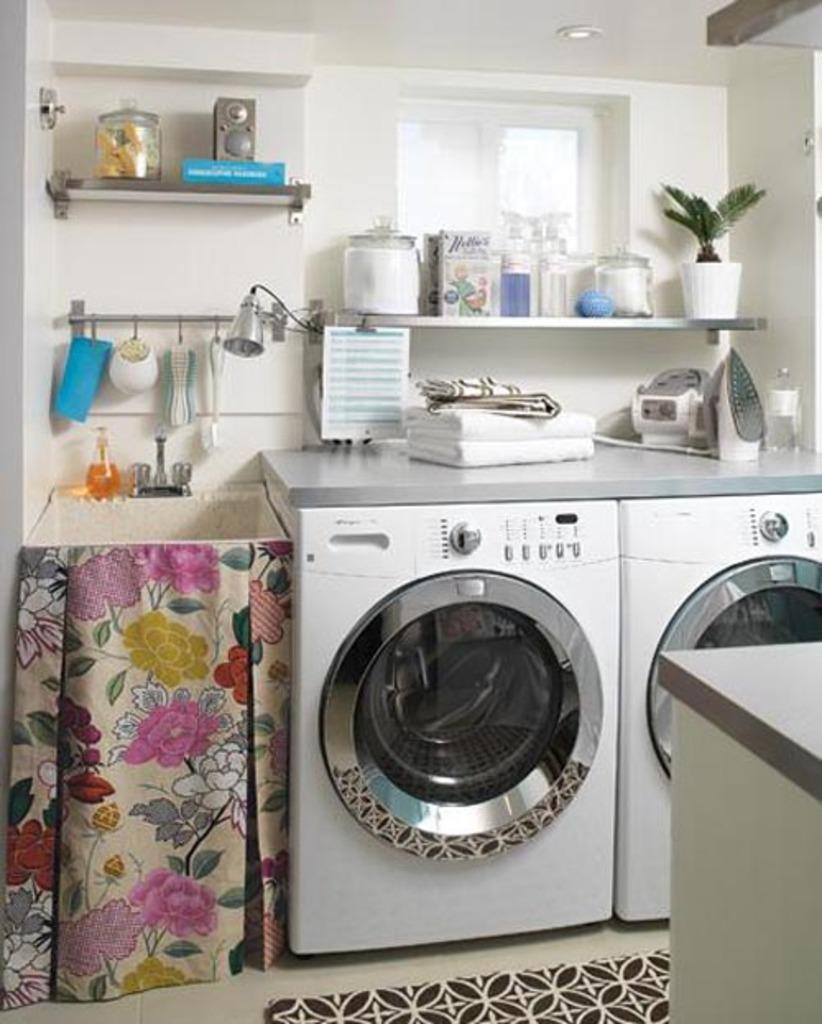How many washing machines can be seen in the image? There are two washing machines in the image. What is another appliance visible in the image? There is an iron box in the image. What items are related to laundry in the image? There are clothes and vessels in the image. What type of storage can be seen in the image? There are shelves in the image. Is there any greenery present in the image? Yes, there is a plant in the image. What architectural features can be seen in the image? There is a window and a wall in the image. Where is the drawer with the yarn located in the image? There is no drawer or yarn present in the image. What type of ray is emitting light from the wall in the image? There is no ray emitting light from the wall in the image; the light source is not specified. 